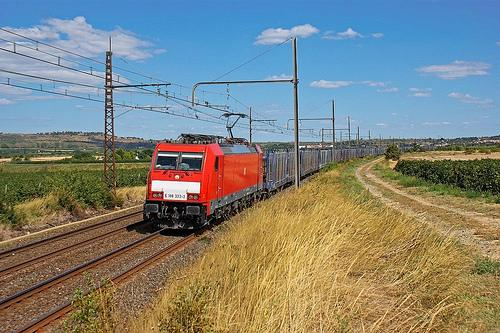Which colors can be primarily seen in the sky within the image? Blue and white. Can you identify any specific details about the train engine in the image? The train engine is red, has a front window, headlights, and a number. Count the total number of distinct clouds (image) mentioned in the image information. Five clouds. In a narrative format, describe the environment around the train tracks based on the given information. The train tracks stretch across a grassy field, bordered by dusty dirt roads and green hedges. A small tree stands nearby, while tall, dry grass rustles in the breeze. Farther away, high brown grass grows, and sparse white clouds float in the clear blue sky. What type of grass surrounds the train tracks and how does it appear? Long, dry, and brown grass. Explain the condition of the train tracks as per the given image details. The train tracks are long, rusty, and have stones and gravel beside them. Mention the numbers visible on the front of the train, and what color are they in? Black text numbers can be seen, but the specific digits are not provided. List three different objects that can be found in the sky portion of the image. Blue sky, small white clouds, and a rusted old power pole. Provide a short and simple description of the primary object in the image. A red train engine is on the tracks. How many sets of railroad tracks are there in the image, and what surrounds them? Two sets of railroad tracks, surrounded by dirt road, grass, and bushes. 